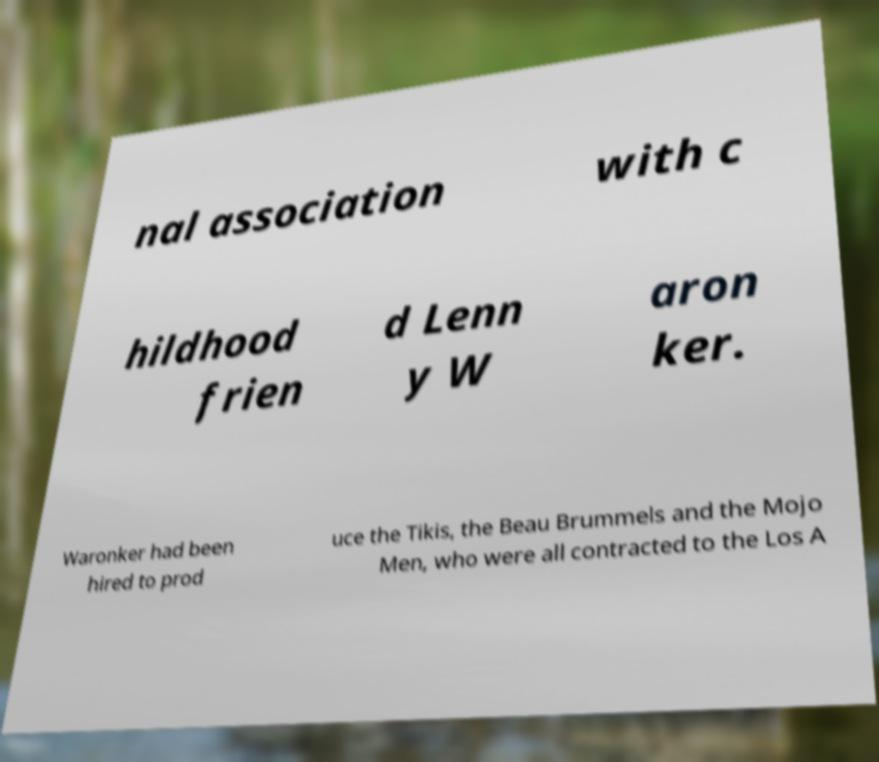There's text embedded in this image that I need extracted. Can you transcribe it verbatim? nal association with c hildhood frien d Lenn y W aron ker. Waronker had been hired to prod uce the Tikis, the Beau Brummels and the Mojo Men, who were all contracted to the Los A 